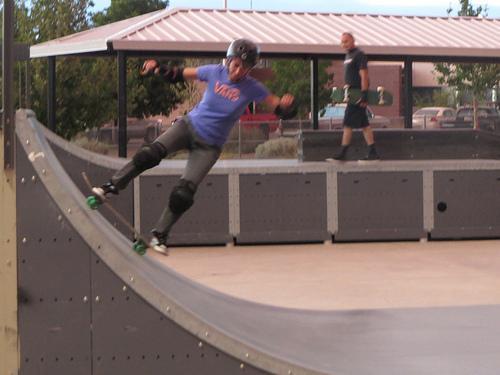How many people are shown?
Give a very brief answer. 2. 